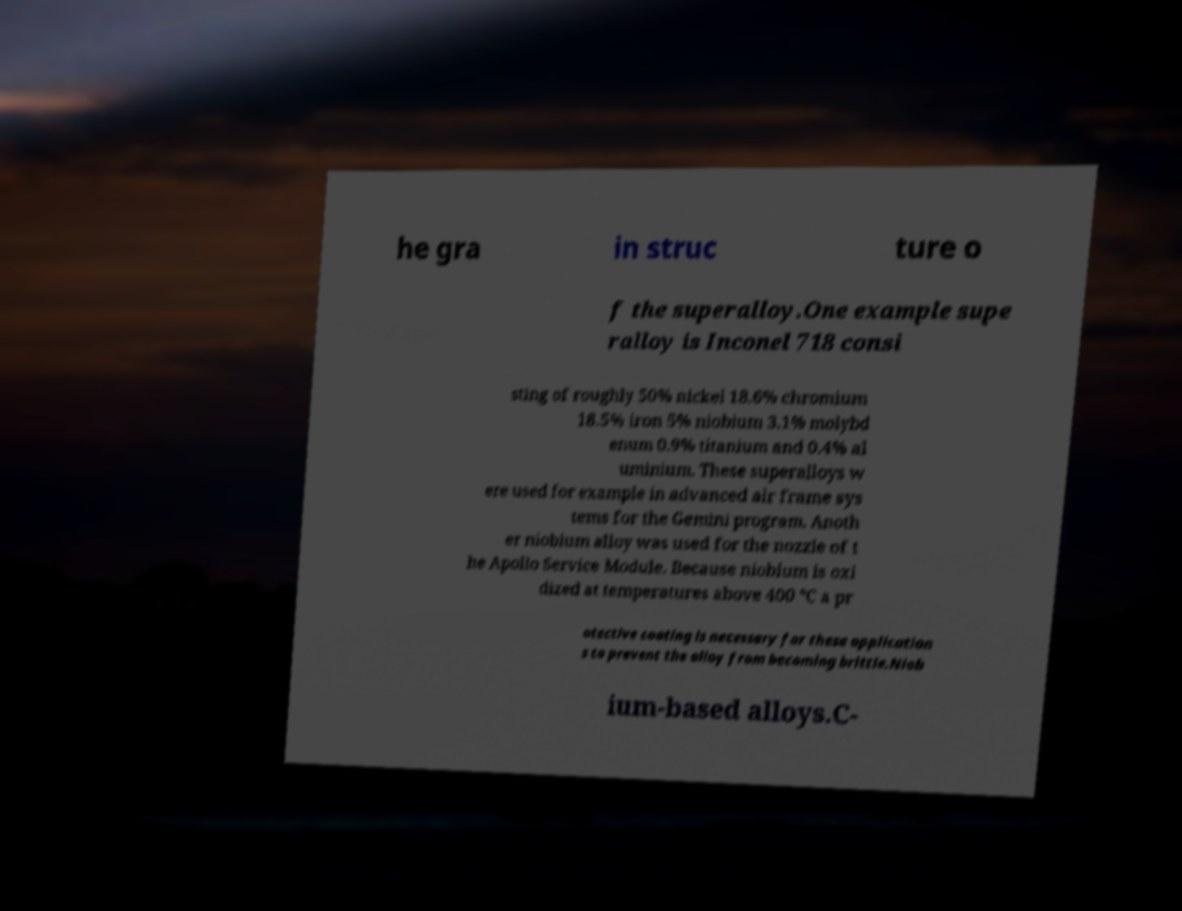Please read and relay the text visible in this image. What does it say? he gra in struc ture o f the superalloy.One example supe ralloy is Inconel 718 consi sting of roughly 50% nickel 18.6% chromium 18.5% iron 5% niobium 3.1% molybd enum 0.9% titanium and 0.4% al uminium. These superalloys w ere used for example in advanced air frame sys tems for the Gemini program. Anoth er niobium alloy was used for the nozzle of t he Apollo Service Module. Because niobium is oxi dized at temperatures above 400 °C a pr otective coating is necessary for these application s to prevent the alloy from becoming brittle.Niob ium-based alloys.C- 